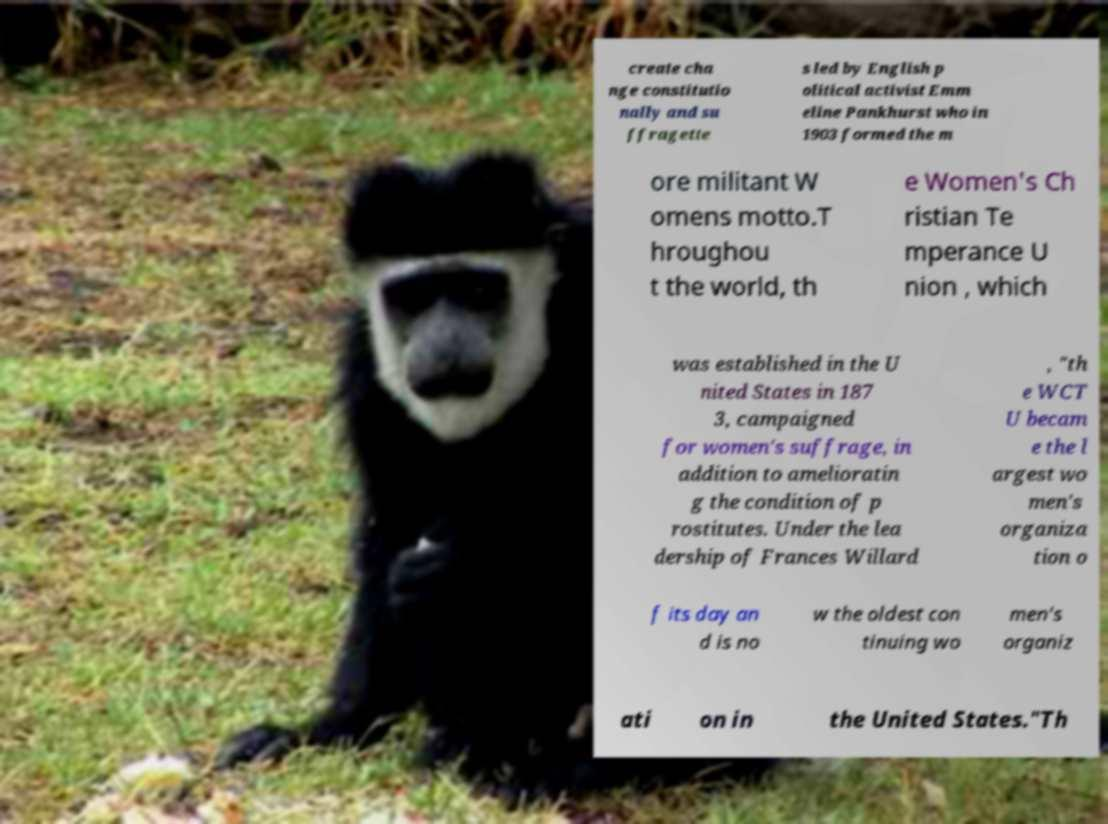Can you accurately transcribe the text from the provided image for me? create cha nge constitutio nally and su ffragette s led by English p olitical activist Emm eline Pankhurst who in 1903 formed the m ore militant W omens motto.T hroughou t the world, th e Women's Ch ristian Te mperance U nion , which was established in the U nited States in 187 3, campaigned for women's suffrage, in addition to amelioratin g the condition of p rostitutes. Under the lea dership of Frances Willard , "th e WCT U becam e the l argest wo men's organiza tion o f its day an d is no w the oldest con tinuing wo men's organiz ati on in the United States."Th 